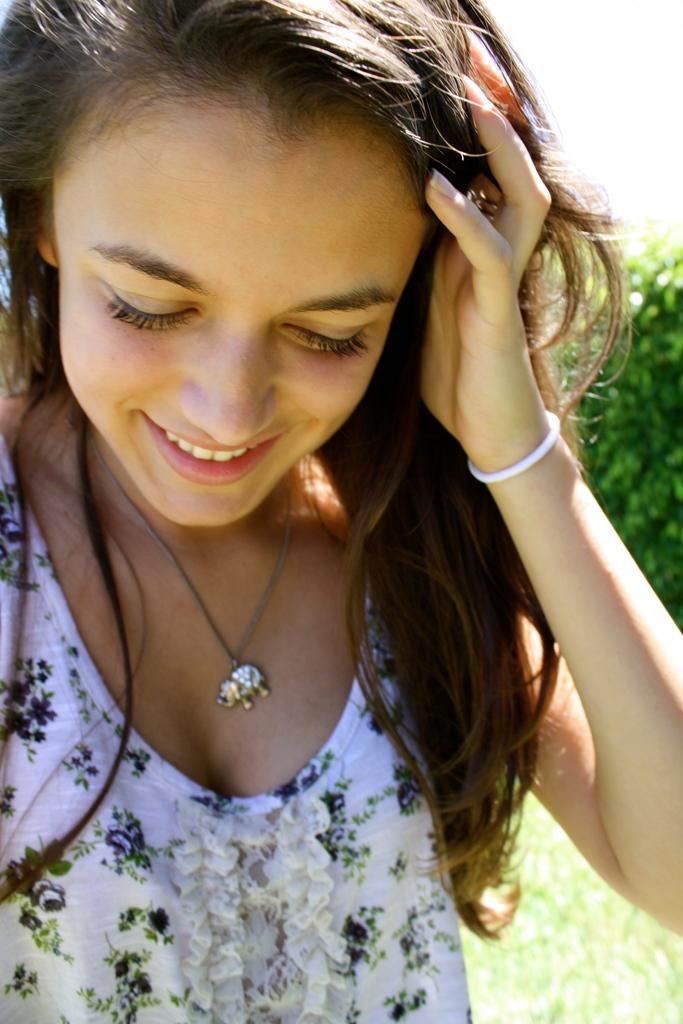Who is present in the image? There is a girl in the image. What is the girl's expression in the image? The girl is smiling in the image. What type of terrain is visible at the bottom of the image? There is grass at the bottom of the image. What can be seen in the background of the image? There is a tree in the background of the image. What type of canvas is the girl painting in the image? There is no canvas or painting activity present in the image. 